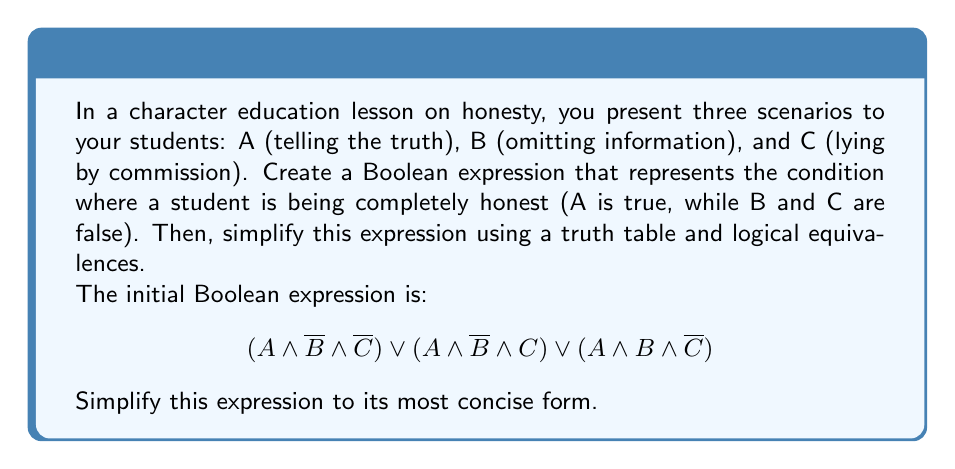Provide a solution to this math problem. Let's approach this step-by-step:

1) First, let's create a truth table for the given expression:

   $$
   \begin{array}{|c|c|c|c|c|c|}
   \hline
   A & B & C & A \land \overline{B} \land \overline{C} & A \land \overline{B} \land C & A \land B \land \overline{C} & \text{Result} \\
   \hline
   0 & 0 & 0 & 0 & 0 & 0 & 0 \\
   0 & 0 & 1 & 0 & 0 & 0 & 0 \\
   0 & 1 & 0 & 0 & 0 & 0 & 0 \\
   0 & 1 & 1 & 0 & 0 & 0 & 0 \\
   1 & 0 & 0 & 1 & 0 & 0 & 1 \\
   1 & 0 & 1 & 0 & 1 & 0 & 1 \\
   1 & 1 & 0 & 0 & 0 & 1 & 1 \\
   1 & 1 & 1 & 0 & 0 & 0 & 0 \\
   \hline
   \end{array}
   $$

2) From the truth table, we can see that the expression is true when A is true and either B or C (or both) are false.

3) We can simplify this using logical equivalences:

   $$(A \land \overline{B} \land \overline{C}) \lor (A \land \overline{B} \land C) \lor (A \land B \land \overline{C})$$
   
   $= A \land (\overline{B} \land \overline{C} \lor \overline{B} \land C \lor B \land \overline{C})$ (Distributive property)
   
   $= A \land (\overline{B}(\overline{C} \lor C) \lor B \land \overline{C})$ (Distributive property)
   
   $= A \land (\overline{B} \lor (B \land \overline{C}))$ (Complement law: $\overline{C} \lor C = 1$)
   
   $= A \land (\overline{B} \lor \overline{C})$ (Absorption law: $\overline{B} \lor (B \land \overline{C}) = \overline{B} \lor \overline{C}$)

4) This final expression, $A \land (\overline{B} \lor \overline{C})$, is the simplest form of the original expression.

5) We can verify this by creating a truth table for this simplified expression and comparing it to the original:

   $$
   \begin{array}{|c|c|c|c|}
   \hline
   A & B & C & A \land (\overline{B} \lor \overline{C}) \\
   \hline
   0 & 0 & 0 & 0 \\
   0 & 0 & 1 & 0 \\
   0 & 1 & 0 & 0 \\
   0 & 1 & 1 & 0 \\
   1 & 0 & 0 & 1 \\
   1 & 0 & 1 & 1 \\
   1 & 1 & 0 & 1 \\
   1 & 1 & 1 & 0 \\
   \hline
   \end{array}
   $$

   This matches the result column in our original truth table, confirming our simplification.
Answer: $A \land (\overline{B} \lor \overline{C})$ 